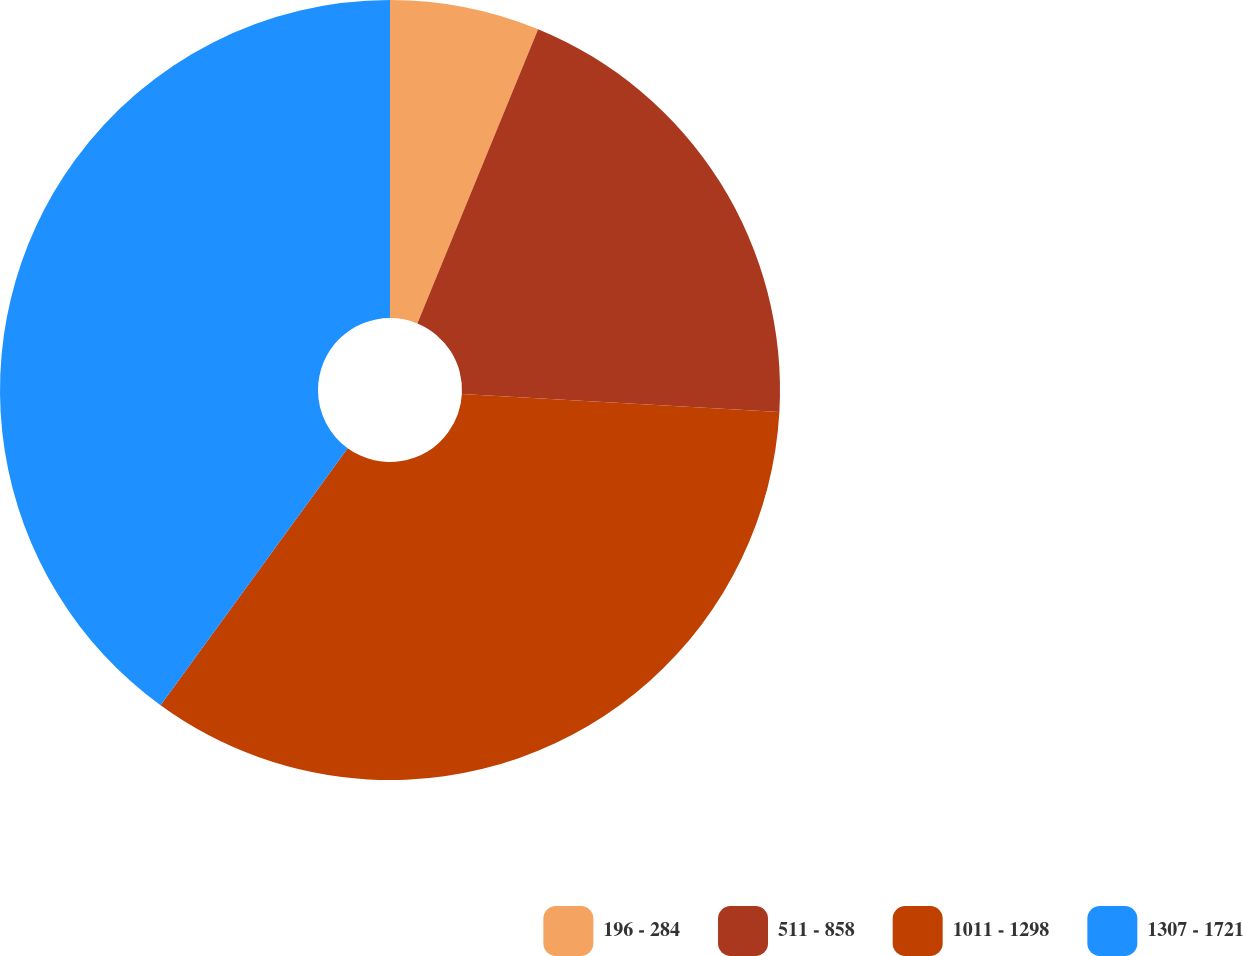Convert chart to OTSL. <chart><loc_0><loc_0><loc_500><loc_500><pie_chart><fcel>196 - 284<fcel>511 - 858<fcel>1011 - 1298<fcel>1307 - 1721<nl><fcel>6.2%<fcel>19.7%<fcel>34.11%<fcel>39.99%<nl></chart> 